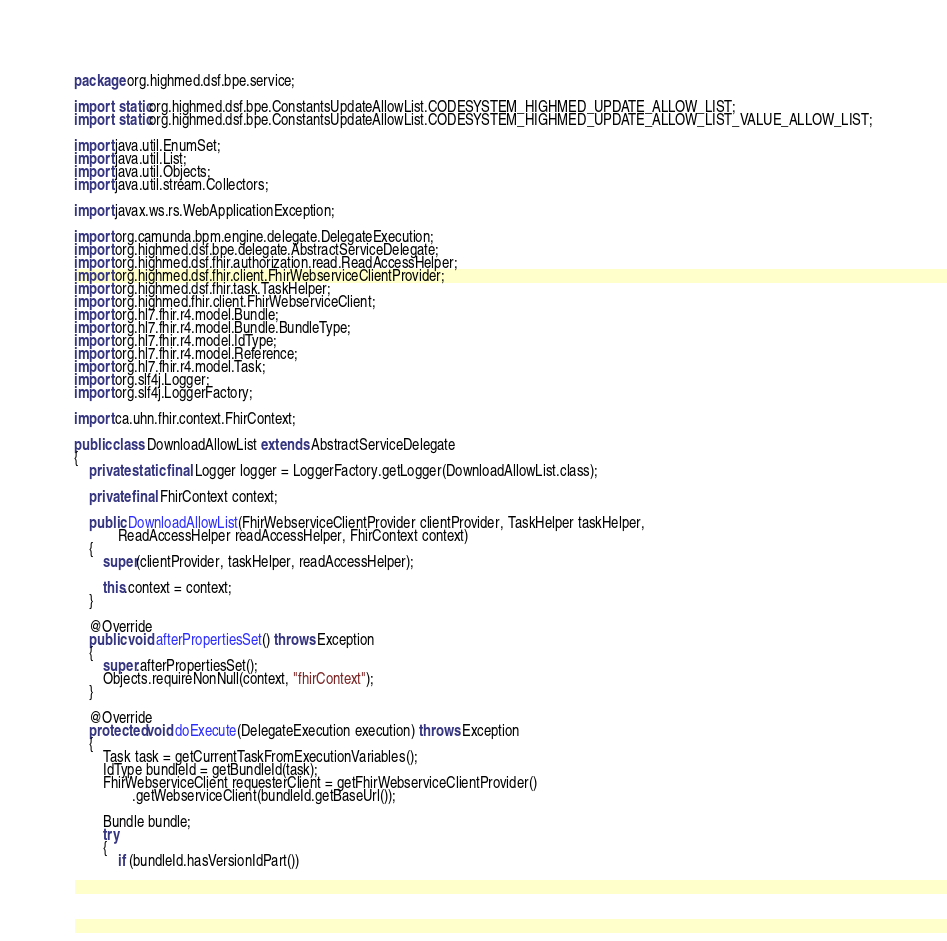Convert code to text. <code><loc_0><loc_0><loc_500><loc_500><_Java_>package org.highmed.dsf.bpe.service;

import static org.highmed.dsf.bpe.ConstantsUpdateAllowList.CODESYSTEM_HIGHMED_UPDATE_ALLOW_LIST;
import static org.highmed.dsf.bpe.ConstantsUpdateAllowList.CODESYSTEM_HIGHMED_UPDATE_ALLOW_LIST_VALUE_ALLOW_LIST;

import java.util.EnumSet;
import java.util.List;
import java.util.Objects;
import java.util.stream.Collectors;

import javax.ws.rs.WebApplicationException;

import org.camunda.bpm.engine.delegate.DelegateExecution;
import org.highmed.dsf.bpe.delegate.AbstractServiceDelegate;
import org.highmed.dsf.fhir.authorization.read.ReadAccessHelper;
import org.highmed.dsf.fhir.client.FhirWebserviceClientProvider;
import org.highmed.dsf.fhir.task.TaskHelper;
import org.highmed.fhir.client.FhirWebserviceClient;
import org.hl7.fhir.r4.model.Bundle;
import org.hl7.fhir.r4.model.Bundle.BundleType;
import org.hl7.fhir.r4.model.IdType;
import org.hl7.fhir.r4.model.Reference;
import org.hl7.fhir.r4.model.Task;
import org.slf4j.Logger;
import org.slf4j.LoggerFactory;

import ca.uhn.fhir.context.FhirContext;

public class DownloadAllowList extends AbstractServiceDelegate
{
	private static final Logger logger = LoggerFactory.getLogger(DownloadAllowList.class);

	private final FhirContext context;

	public DownloadAllowList(FhirWebserviceClientProvider clientProvider, TaskHelper taskHelper,
			ReadAccessHelper readAccessHelper, FhirContext context)
	{
		super(clientProvider, taskHelper, readAccessHelper);

		this.context = context;
	}

	@Override
	public void afterPropertiesSet() throws Exception
	{
		super.afterPropertiesSet();
		Objects.requireNonNull(context, "fhirContext");
	}

	@Override
	protected void doExecute(DelegateExecution execution) throws Exception
	{
		Task task = getCurrentTaskFromExecutionVariables();
		IdType bundleId = getBundleId(task);
		FhirWebserviceClient requesterClient = getFhirWebserviceClientProvider()
				.getWebserviceClient(bundleId.getBaseUrl());

		Bundle bundle;
		try
		{
			if (bundleId.hasVersionIdPart())</code> 